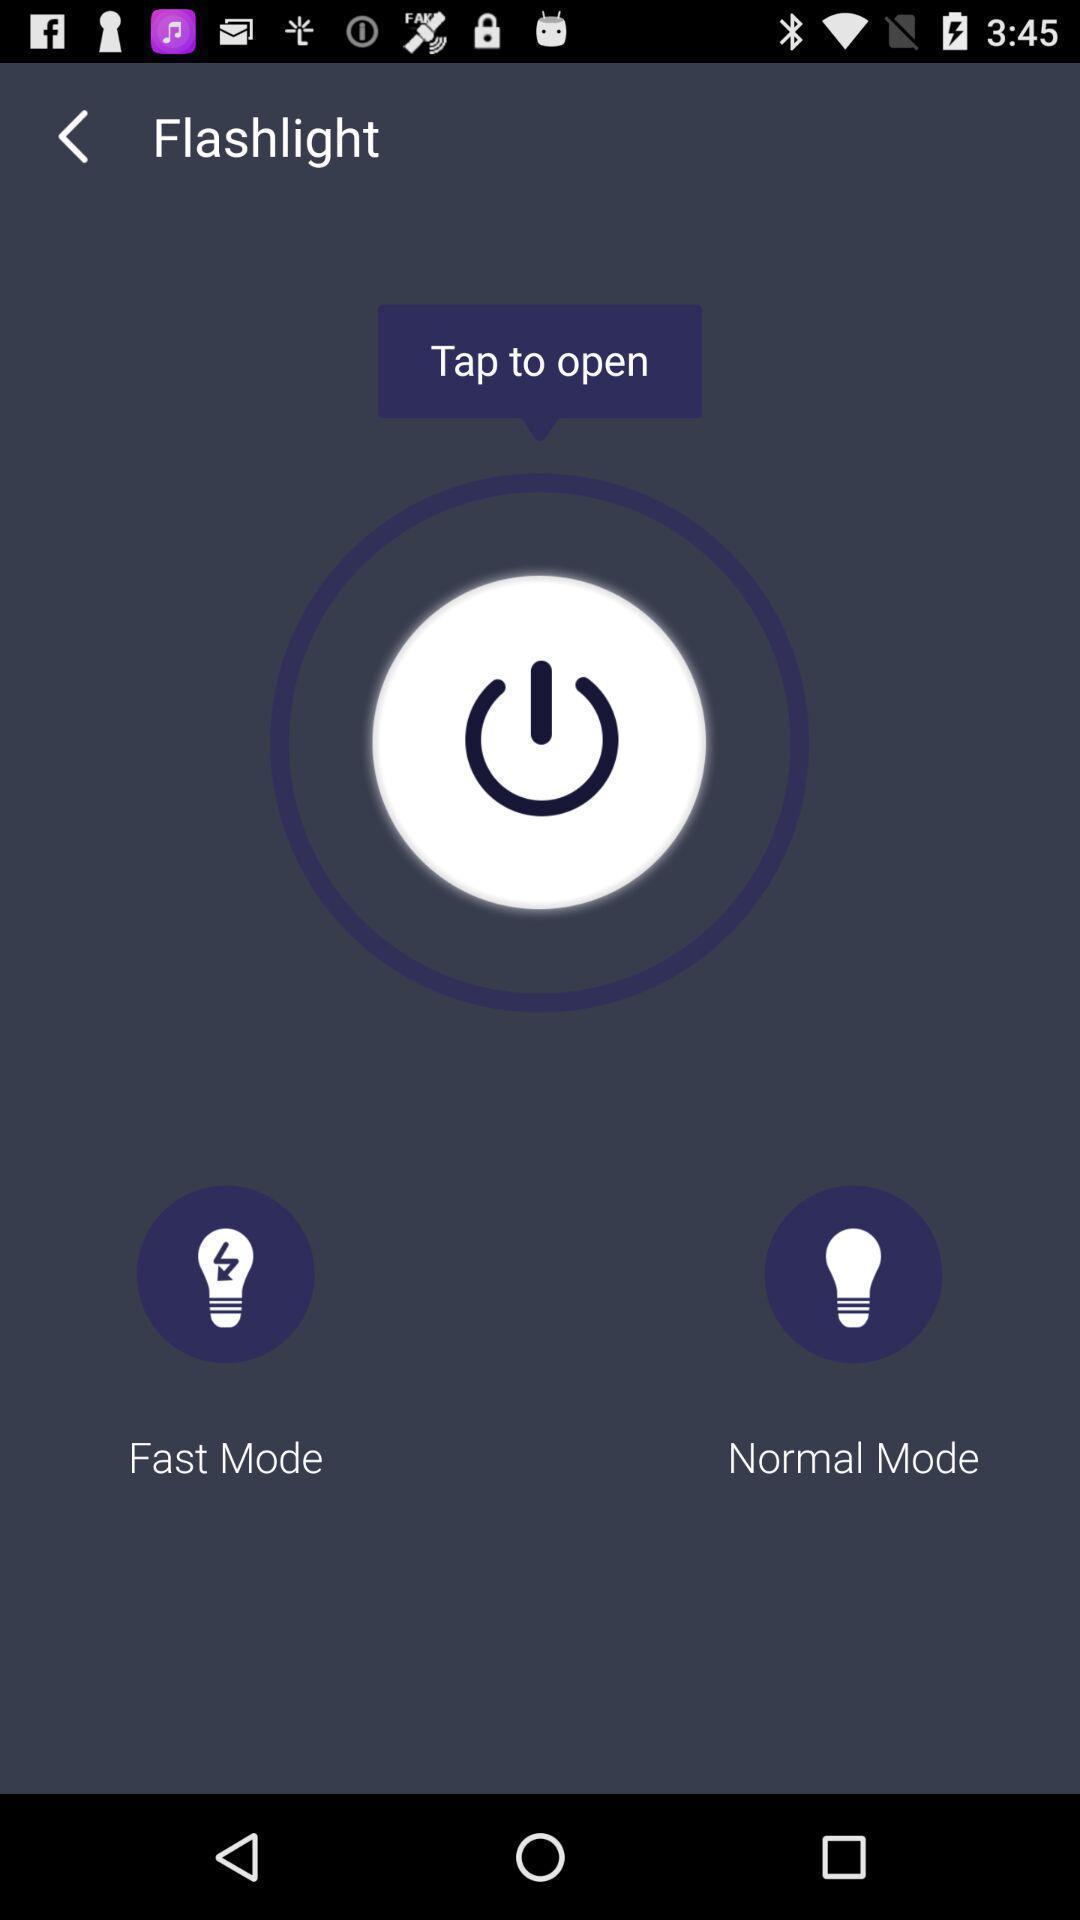Explain what's happening in this screen capture. Page with fast and normal mode options. 